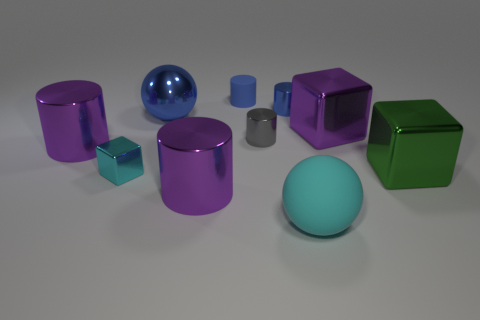Subtract 2 cylinders. How many cylinders are left? 3 Subtract all tiny blue shiny cylinders. How many cylinders are left? 4 Subtract all gray cylinders. How many cylinders are left? 4 Subtract all yellow cylinders. Subtract all cyan blocks. How many cylinders are left? 5 Subtract all cubes. How many objects are left? 7 Subtract all big brown metallic balls. Subtract all blue things. How many objects are left? 7 Add 3 big green metallic things. How many big green metallic things are left? 4 Add 4 tiny blue rubber things. How many tiny blue rubber things exist? 5 Subtract 1 blue balls. How many objects are left? 9 